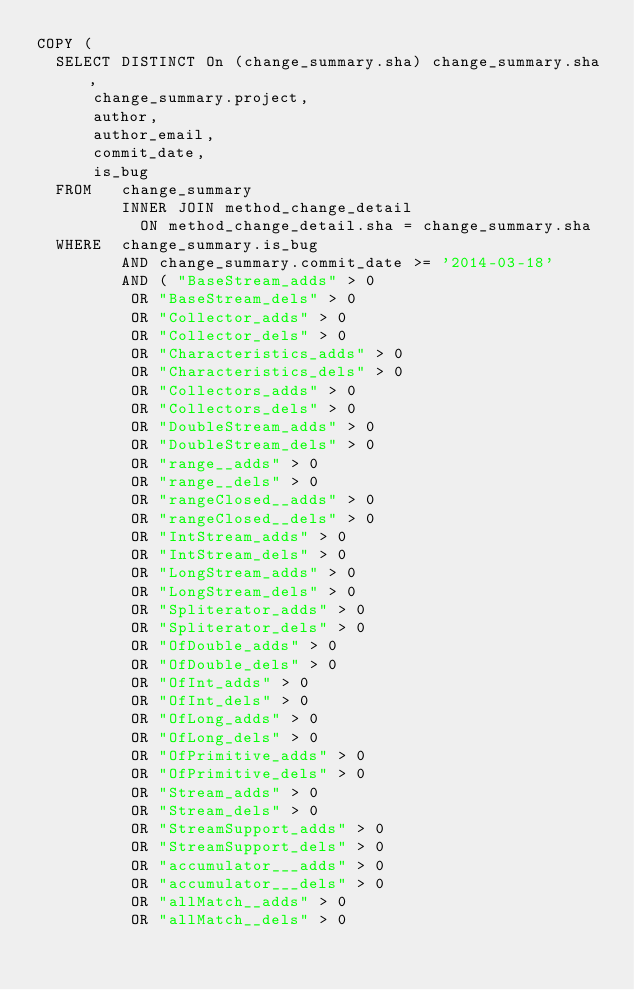<code> <loc_0><loc_0><loc_500><loc_500><_SQL_>COPY (
	SELECT DISTINCT On (change_summary.sha) change_summary.sha, 
			change_summary.project, 
			author, 
			author_email, 
			commit_date, 
			is_bug 
	FROM   change_summary 
	       INNER JOIN method_change_detail 
		       ON method_change_detail.sha = change_summary.sha 
	WHERE  change_summary.is_bug 
	       AND change_summary.commit_date >= '2014-03-18' 
	       AND ( "BaseStream_adds" > 0 
		      OR "BaseStream_dels" > 0 
		      OR "Collector_adds" > 0 
		      OR "Collector_dels" > 0 
		      OR "Characteristics_adds" > 0 
		      OR "Characteristics_dels" > 0 
		      OR "Collectors_adds" > 0 
		      OR "Collectors_dels" > 0 
		      OR "DoubleStream_adds" > 0 
		      OR "DoubleStream_dels" > 0 
		      OR "range__adds" > 0 
		      OR "range__dels" > 0 
		      OR "rangeClosed__adds" > 0 
		      OR "rangeClosed__dels" > 0 
		      OR "IntStream_adds" > 0 
		      OR "IntStream_dels" > 0 
		      OR "LongStream_adds" > 0 
		      OR "LongStream_dels" > 0 
		      OR "Spliterator_adds" > 0 
		      OR "Spliterator_dels" > 0 
		      OR "OfDouble_adds" > 0 
		      OR "OfDouble_dels" > 0 
		      OR "OfInt_adds" > 0 
		      OR "OfInt_dels" > 0 
		      OR "OfLong_adds" > 0 
		      OR "OfLong_dels" > 0 
		      OR "OfPrimitive_adds" > 0 
		      OR "OfPrimitive_dels" > 0 
		      OR "Stream_adds" > 0 
		      OR "Stream_dels" > 0 
		      OR "StreamSupport_adds" > 0 
		      OR "StreamSupport_dels" > 0 
		      OR "accumulator___adds" > 0 
		      OR "accumulator___dels" > 0 
		      OR "allMatch__adds" > 0 
		      OR "allMatch__dels" > 0 </code> 